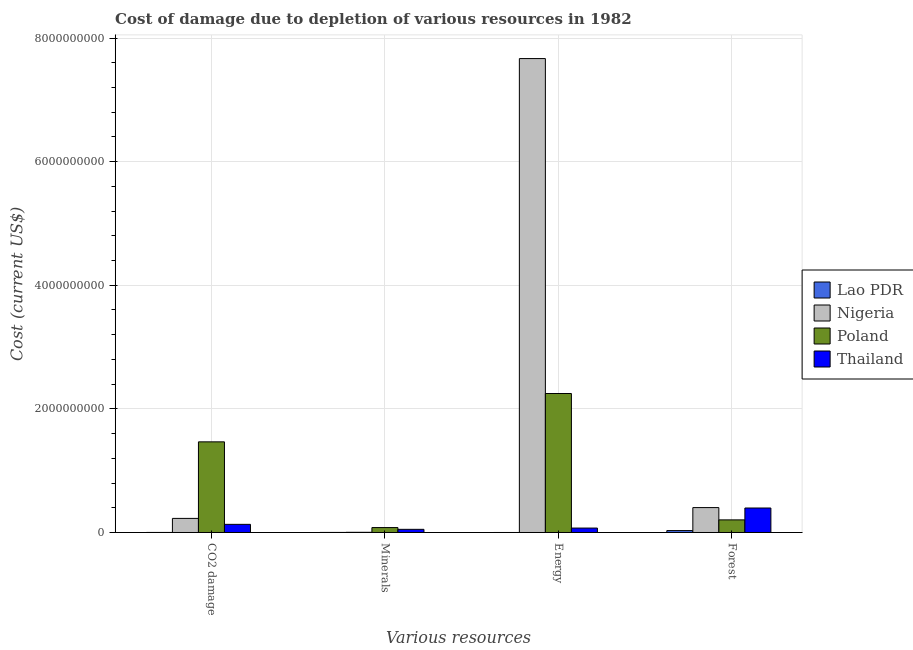How many different coloured bars are there?
Your answer should be compact. 4. How many groups of bars are there?
Your answer should be very brief. 4. Are the number of bars per tick equal to the number of legend labels?
Make the answer very short. Yes. Are the number of bars on each tick of the X-axis equal?
Ensure brevity in your answer.  Yes. How many bars are there on the 3rd tick from the left?
Make the answer very short. 4. How many bars are there on the 1st tick from the right?
Your answer should be compact. 4. What is the label of the 4th group of bars from the left?
Make the answer very short. Forest. What is the cost of damage due to depletion of forests in Lao PDR?
Provide a short and direct response. 3.10e+07. Across all countries, what is the maximum cost of damage due to depletion of minerals?
Your answer should be very brief. 7.95e+07. Across all countries, what is the minimum cost of damage due to depletion of forests?
Provide a short and direct response. 3.10e+07. In which country was the cost of damage due to depletion of forests minimum?
Your answer should be compact. Lao PDR. What is the total cost of damage due to depletion of forests in the graph?
Make the answer very short. 1.03e+09. What is the difference between the cost of damage due to depletion of forests in Thailand and that in Lao PDR?
Your answer should be compact. 3.65e+08. What is the difference between the cost of damage due to depletion of minerals in Nigeria and the cost of damage due to depletion of coal in Lao PDR?
Your answer should be very brief. 2.46e+06. What is the average cost of damage due to depletion of coal per country?
Make the answer very short. 4.57e+08. What is the difference between the cost of damage due to depletion of minerals and cost of damage due to depletion of energy in Thailand?
Provide a short and direct response. -2.06e+07. What is the ratio of the cost of damage due to depletion of energy in Lao PDR to that in Poland?
Provide a succinct answer. 1.882931711154583e-6. Is the cost of damage due to depletion of forests in Lao PDR less than that in Nigeria?
Your response must be concise. Yes. What is the difference between the highest and the second highest cost of damage due to depletion of energy?
Ensure brevity in your answer.  5.42e+09. What is the difference between the highest and the lowest cost of damage due to depletion of energy?
Keep it short and to the point. 7.67e+09. What does the 3rd bar from the right in Minerals represents?
Give a very brief answer. Nigeria. Is it the case that in every country, the sum of the cost of damage due to depletion of coal and cost of damage due to depletion of minerals is greater than the cost of damage due to depletion of energy?
Your response must be concise. No. How many bars are there?
Provide a succinct answer. 16. Are all the bars in the graph horizontal?
Your response must be concise. No. How many countries are there in the graph?
Keep it short and to the point. 4. Are the values on the major ticks of Y-axis written in scientific E-notation?
Provide a succinct answer. No. Does the graph contain any zero values?
Provide a short and direct response. No. Does the graph contain grids?
Your response must be concise. Yes. What is the title of the graph?
Offer a very short reply. Cost of damage due to depletion of various resources in 1982 . What is the label or title of the X-axis?
Your response must be concise. Various resources. What is the label or title of the Y-axis?
Your answer should be compact. Cost (current US$). What is the Cost (current US$) of Lao PDR in CO2 damage?
Provide a short and direct response. 5.48e+05. What is the Cost (current US$) in Nigeria in CO2 damage?
Your answer should be compact. 2.28e+08. What is the Cost (current US$) of Poland in CO2 damage?
Offer a terse response. 1.47e+09. What is the Cost (current US$) of Thailand in CO2 damage?
Keep it short and to the point. 1.32e+08. What is the Cost (current US$) of Lao PDR in Minerals?
Ensure brevity in your answer.  9.86e+05. What is the Cost (current US$) in Nigeria in Minerals?
Your answer should be compact. 3.01e+06. What is the Cost (current US$) of Poland in Minerals?
Offer a terse response. 7.95e+07. What is the Cost (current US$) in Thailand in Minerals?
Your answer should be very brief. 5.09e+07. What is the Cost (current US$) of Lao PDR in Energy?
Keep it short and to the point. 4233.79. What is the Cost (current US$) in Nigeria in Energy?
Offer a terse response. 7.67e+09. What is the Cost (current US$) in Poland in Energy?
Offer a terse response. 2.25e+09. What is the Cost (current US$) in Thailand in Energy?
Ensure brevity in your answer.  7.15e+07. What is the Cost (current US$) in Lao PDR in Forest?
Keep it short and to the point. 3.10e+07. What is the Cost (current US$) of Nigeria in Forest?
Provide a succinct answer. 4.03e+08. What is the Cost (current US$) in Poland in Forest?
Provide a succinct answer. 2.04e+08. What is the Cost (current US$) in Thailand in Forest?
Provide a succinct answer. 3.96e+08. Across all Various resources, what is the maximum Cost (current US$) in Lao PDR?
Your answer should be very brief. 3.10e+07. Across all Various resources, what is the maximum Cost (current US$) in Nigeria?
Offer a terse response. 7.67e+09. Across all Various resources, what is the maximum Cost (current US$) of Poland?
Offer a terse response. 2.25e+09. Across all Various resources, what is the maximum Cost (current US$) of Thailand?
Provide a short and direct response. 3.96e+08. Across all Various resources, what is the minimum Cost (current US$) in Lao PDR?
Your answer should be compact. 4233.79. Across all Various resources, what is the minimum Cost (current US$) in Nigeria?
Give a very brief answer. 3.01e+06. Across all Various resources, what is the minimum Cost (current US$) in Poland?
Your answer should be very brief. 7.95e+07. Across all Various resources, what is the minimum Cost (current US$) of Thailand?
Offer a very short reply. 5.09e+07. What is the total Cost (current US$) of Lao PDR in the graph?
Keep it short and to the point. 3.25e+07. What is the total Cost (current US$) in Nigeria in the graph?
Your answer should be very brief. 8.30e+09. What is the total Cost (current US$) of Poland in the graph?
Keep it short and to the point. 4.00e+09. What is the total Cost (current US$) of Thailand in the graph?
Make the answer very short. 6.50e+08. What is the difference between the Cost (current US$) of Lao PDR in CO2 damage and that in Minerals?
Your answer should be compact. -4.38e+05. What is the difference between the Cost (current US$) of Nigeria in CO2 damage and that in Minerals?
Make the answer very short. 2.25e+08. What is the difference between the Cost (current US$) of Poland in CO2 damage and that in Minerals?
Ensure brevity in your answer.  1.39e+09. What is the difference between the Cost (current US$) of Thailand in CO2 damage and that in Minerals?
Provide a short and direct response. 8.08e+07. What is the difference between the Cost (current US$) in Lao PDR in CO2 damage and that in Energy?
Offer a very short reply. 5.43e+05. What is the difference between the Cost (current US$) of Nigeria in CO2 damage and that in Energy?
Provide a succinct answer. -7.44e+09. What is the difference between the Cost (current US$) in Poland in CO2 damage and that in Energy?
Make the answer very short. -7.82e+08. What is the difference between the Cost (current US$) in Thailand in CO2 damage and that in Energy?
Your answer should be very brief. 6.02e+07. What is the difference between the Cost (current US$) of Lao PDR in CO2 damage and that in Forest?
Your answer should be very brief. -3.05e+07. What is the difference between the Cost (current US$) in Nigeria in CO2 damage and that in Forest?
Your answer should be very brief. -1.75e+08. What is the difference between the Cost (current US$) of Poland in CO2 damage and that in Forest?
Make the answer very short. 1.26e+09. What is the difference between the Cost (current US$) in Thailand in CO2 damage and that in Forest?
Keep it short and to the point. -2.64e+08. What is the difference between the Cost (current US$) of Lao PDR in Minerals and that in Energy?
Your answer should be compact. 9.82e+05. What is the difference between the Cost (current US$) of Nigeria in Minerals and that in Energy?
Offer a very short reply. -7.66e+09. What is the difference between the Cost (current US$) of Poland in Minerals and that in Energy?
Keep it short and to the point. -2.17e+09. What is the difference between the Cost (current US$) in Thailand in Minerals and that in Energy?
Provide a short and direct response. -2.06e+07. What is the difference between the Cost (current US$) of Lao PDR in Minerals and that in Forest?
Provide a succinct answer. -3.00e+07. What is the difference between the Cost (current US$) in Nigeria in Minerals and that in Forest?
Provide a short and direct response. -4.00e+08. What is the difference between the Cost (current US$) of Poland in Minerals and that in Forest?
Make the answer very short. -1.25e+08. What is the difference between the Cost (current US$) of Thailand in Minerals and that in Forest?
Make the answer very short. -3.45e+08. What is the difference between the Cost (current US$) of Lao PDR in Energy and that in Forest?
Give a very brief answer. -3.10e+07. What is the difference between the Cost (current US$) in Nigeria in Energy and that in Forest?
Provide a succinct answer. 7.26e+09. What is the difference between the Cost (current US$) of Poland in Energy and that in Forest?
Ensure brevity in your answer.  2.04e+09. What is the difference between the Cost (current US$) of Thailand in Energy and that in Forest?
Your answer should be very brief. -3.24e+08. What is the difference between the Cost (current US$) of Lao PDR in CO2 damage and the Cost (current US$) of Nigeria in Minerals?
Your answer should be compact. -2.46e+06. What is the difference between the Cost (current US$) in Lao PDR in CO2 damage and the Cost (current US$) in Poland in Minerals?
Offer a very short reply. -7.89e+07. What is the difference between the Cost (current US$) in Lao PDR in CO2 damage and the Cost (current US$) in Thailand in Minerals?
Your answer should be compact. -5.03e+07. What is the difference between the Cost (current US$) of Nigeria in CO2 damage and the Cost (current US$) of Poland in Minerals?
Ensure brevity in your answer.  1.48e+08. What is the difference between the Cost (current US$) of Nigeria in CO2 damage and the Cost (current US$) of Thailand in Minerals?
Make the answer very short. 1.77e+08. What is the difference between the Cost (current US$) in Poland in CO2 damage and the Cost (current US$) in Thailand in Minerals?
Your answer should be very brief. 1.42e+09. What is the difference between the Cost (current US$) in Lao PDR in CO2 damage and the Cost (current US$) in Nigeria in Energy?
Your answer should be very brief. -7.67e+09. What is the difference between the Cost (current US$) of Lao PDR in CO2 damage and the Cost (current US$) of Poland in Energy?
Your answer should be very brief. -2.25e+09. What is the difference between the Cost (current US$) of Lao PDR in CO2 damage and the Cost (current US$) of Thailand in Energy?
Offer a very short reply. -7.09e+07. What is the difference between the Cost (current US$) in Nigeria in CO2 damage and the Cost (current US$) in Poland in Energy?
Give a very brief answer. -2.02e+09. What is the difference between the Cost (current US$) of Nigeria in CO2 damage and the Cost (current US$) of Thailand in Energy?
Ensure brevity in your answer.  1.56e+08. What is the difference between the Cost (current US$) of Poland in CO2 damage and the Cost (current US$) of Thailand in Energy?
Make the answer very short. 1.39e+09. What is the difference between the Cost (current US$) of Lao PDR in CO2 damage and the Cost (current US$) of Nigeria in Forest?
Make the answer very short. -4.02e+08. What is the difference between the Cost (current US$) of Lao PDR in CO2 damage and the Cost (current US$) of Poland in Forest?
Keep it short and to the point. -2.03e+08. What is the difference between the Cost (current US$) of Lao PDR in CO2 damage and the Cost (current US$) of Thailand in Forest?
Your response must be concise. -3.95e+08. What is the difference between the Cost (current US$) in Nigeria in CO2 damage and the Cost (current US$) in Poland in Forest?
Your answer should be very brief. 2.38e+07. What is the difference between the Cost (current US$) in Nigeria in CO2 damage and the Cost (current US$) in Thailand in Forest?
Keep it short and to the point. -1.68e+08. What is the difference between the Cost (current US$) of Poland in CO2 damage and the Cost (current US$) of Thailand in Forest?
Your answer should be very brief. 1.07e+09. What is the difference between the Cost (current US$) of Lao PDR in Minerals and the Cost (current US$) of Nigeria in Energy?
Offer a very short reply. -7.67e+09. What is the difference between the Cost (current US$) of Lao PDR in Minerals and the Cost (current US$) of Poland in Energy?
Your answer should be compact. -2.25e+09. What is the difference between the Cost (current US$) of Lao PDR in Minerals and the Cost (current US$) of Thailand in Energy?
Offer a terse response. -7.05e+07. What is the difference between the Cost (current US$) of Nigeria in Minerals and the Cost (current US$) of Poland in Energy?
Make the answer very short. -2.25e+09. What is the difference between the Cost (current US$) in Nigeria in Minerals and the Cost (current US$) in Thailand in Energy?
Offer a very short reply. -6.85e+07. What is the difference between the Cost (current US$) of Poland in Minerals and the Cost (current US$) of Thailand in Energy?
Provide a succinct answer. 7.99e+06. What is the difference between the Cost (current US$) in Lao PDR in Minerals and the Cost (current US$) in Nigeria in Forest?
Ensure brevity in your answer.  -4.02e+08. What is the difference between the Cost (current US$) in Lao PDR in Minerals and the Cost (current US$) in Poland in Forest?
Offer a very short reply. -2.03e+08. What is the difference between the Cost (current US$) of Lao PDR in Minerals and the Cost (current US$) of Thailand in Forest?
Offer a terse response. -3.95e+08. What is the difference between the Cost (current US$) in Nigeria in Minerals and the Cost (current US$) in Poland in Forest?
Ensure brevity in your answer.  -2.01e+08. What is the difference between the Cost (current US$) in Nigeria in Minerals and the Cost (current US$) in Thailand in Forest?
Your response must be concise. -3.93e+08. What is the difference between the Cost (current US$) in Poland in Minerals and the Cost (current US$) in Thailand in Forest?
Make the answer very short. -3.16e+08. What is the difference between the Cost (current US$) in Lao PDR in Energy and the Cost (current US$) in Nigeria in Forest?
Provide a short and direct response. -4.03e+08. What is the difference between the Cost (current US$) of Lao PDR in Energy and the Cost (current US$) of Poland in Forest?
Offer a very short reply. -2.04e+08. What is the difference between the Cost (current US$) in Lao PDR in Energy and the Cost (current US$) in Thailand in Forest?
Your answer should be compact. -3.96e+08. What is the difference between the Cost (current US$) of Nigeria in Energy and the Cost (current US$) of Poland in Forest?
Your answer should be very brief. 7.46e+09. What is the difference between the Cost (current US$) of Nigeria in Energy and the Cost (current US$) of Thailand in Forest?
Your response must be concise. 7.27e+09. What is the difference between the Cost (current US$) in Poland in Energy and the Cost (current US$) in Thailand in Forest?
Give a very brief answer. 1.85e+09. What is the average Cost (current US$) of Lao PDR per Various resources?
Your answer should be compact. 8.13e+06. What is the average Cost (current US$) in Nigeria per Various resources?
Keep it short and to the point. 2.08e+09. What is the average Cost (current US$) of Poland per Various resources?
Ensure brevity in your answer.  1.00e+09. What is the average Cost (current US$) in Thailand per Various resources?
Your response must be concise. 1.62e+08. What is the difference between the Cost (current US$) of Lao PDR and Cost (current US$) of Nigeria in CO2 damage?
Offer a terse response. -2.27e+08. What is the difference between the Cost (current US$) in Lao PDR and Cost (current US$) in Poland in CO2 damage?
Offer a very short reply. -1.47e+09. What is the difference between the Cost (current US$) of Lao PDR and Cost (current US$) of Thailand in CO2 damage?
Make the answer very short. -1.31e+08. What is the difference between the Cost (current US$) in Nigeria and Cost (current US$) in Poland in CO2 damage?
Ensure brevity in your answer.  -1.24e+09. What is the difference between the Cost (current US$) of Nigeria and Cost (current US$) of Thailand in CO2 damage?
Your answer should be very brief. 9.62e+07. What is the difference between the Cost (current US$) of Poland and Cost (current US$) of Thailand in CO2 damage?
Keep it short and to the point. 1.33e+09. What is the difference between the Cost (current US$) in Lao PDR and Cost (current US$) in Nigeria in Minerals?
Your answer should be compact. -2.02e+06. What is the difference between the Cost (current US$) in Lao PDR and Cost (current US$) in Poland in Minerals?
Make the answer very short. -7.85e+07. What is the difference between the Cost (current US$) of Lao PDR and Cost (current US$) of Thailand in Minerals?
Offer a very short reply. -4.99e+07. What is the difference between the Cost (current US$) of Nigeria and Cost (current US$) of Poland in Minerals?
Give a very brief answer. -7.65e+07. What is the difference between the Cost (current US$) in Nigeria and Cost (current US$) in Thailand in Minerals?
Offer a terse response. -4.79e+07. What is the difference between the Cost (current US$) of Poland and Cost (current US$) of Thailand in Minerals?
Offer a very short reply. 2.86e+07. What is the difference between the Cost (current US$) in Lao PDR and Cost (current US$) in Nigeria in Energy?
Make the answer very short. -7.67e+09. What is the difference between the Cost (current US$) in Lao PDR and Cost (current US$) in Poland in Energy?
Provide a short and direct response. -2.25e+09. What is the difference between the Cost (current US$) of Lao PDR and Cost (current US$) of Thailand in Energy?
Keep it short and to the point. -7.15e+07. What is the difference between the Cost (current US$) in Nigeria and Cost (current US$) in Poland in Energy?
Make the answer very short. 5.42e+09. What is the difference between the Cost (current US$) in Nigeria and Cost (current US$) in Thailand in Energy?
Offer a very short reply. 7.60e+09. What is the difference between the Cost (current US$) in Poland and Cost (current US$) in Thailand in Energy?
Make the answer very short. 2.18e+09. What is the difference between the Cost (current US$) in Lao PDR and Cost (current US$) in Nigeria in Forest?
Ensure brevity in your answer.  -3.72e+08. What is the difference between the Cost (current US$) of Lao PDR and Cost (current US$) of Poland in Forest?
Keep it short and to the point. -1.73e+08. What is the difference between the Cost (current US$) of Lao PDR and Cost (current US$) of Thailand in Forest?
Provide a succinct answer. -3.65e+08. What is the difference between the Cost (current US$) in Nigeria and Cost (current US$) in Poland in Forest?
Your answer should be very brief. 1.99e+08. What is the difference between the Cost (current US$) of Nigeria and Cost (current US$) of Thailand in Forest?
Make the answer very short. 6.84e+06. What is the difference between the Cost (current US$) of Poland and Cost (current US$) of Thailand in Forest?
Provide a succinct answer. -1.92e+08. What is the ratio of the Cost (current US$) of Lao PDR in CO2 damage to that in Minerals?
Ensure brevity in your answer.  0.56. What is the ratio of the Cost (current US$) in Nigeria in CO2 damage to that in Minerals?
Provide a short and direct response. 75.73. What is the ratio of the Cost (current US$) of Poland in CO2 damage to that in Minerals?
Provide a succinct answer. 18.45. What is the ratio of the Cost (current US$) of Thailand in CO2 damage to that in Minerals?
Provide a succinct answer. 2.59. What is the ratio of the Cost (current US$) in Lao PDR in CO2 damage to that in Energy?
Ensure brevity in your answer.  129.35. What is the ratio of the Cost (current US$) in Nigeria in CO2 damage to that in Energy?
Give a very brief answer. 0.03. What is the ratio of the Cost (current US$) of Poland in CO2 damage to that in Energy?
Your answer should be very brief. 0.65. What is the ratio of the Cost (current US$) of Thailand in CO2 damage to that in Energy?
Provide a succinct answer. 1.84. What is the ratio of the Cost (current US$) in Lao PDR in CO2 damage to that in Forest?
Give a very brief answer. 0.02. What is the ratio of the Cost (current US$) of Nigeria in CO2 damage to that in Forest?
Your answer should be compact. 0.57. What is the ratio of the Cost (current US$) in Poland in CO2 damage to that in Forest?
Offer a terse response. 7.19. What is the ratio of the Cost (current US$) in Thailand in CO2 damage to that in Forest?
Ensure brevity in your answer.  0.33. What is the ratio of the Cost (current US$) in Lao PDR in Minerals to that in Energy?
Offer a very short reply. 232.88. What is the ratio of the Cost (current US$) in Nigeria in Minerals to that in Energy?
Provide a succinct answer. 0. What is the ratio of the Cost (current US$) of Poland in Minerals to that in Energy?
Make the answer very short. 0.04. What is the ratio of the Cost (current US$) of Thailand in Minerals to that in Energy?
Give a very brief answer. 0.71. What is the ratio of the Cost (current US$) of Lao PDR in Minerals to that in Forest?
Your answer should be very brief. 0.03. What is the ratio of the Cost (current US$) of Nigeria in Minerals to that in Forest?
Provide a short and direct response. 0.01. What is the ratio of the Cost (current US$) of Poland in Minerals to that in Forest?
Your answer should be compact. 0.39. What is the ratio of the Cost (current US$) of Thailand in Minerals to that in Forest?
Keep it short and to the point. 0.13. What is the ratio of the Cost (current US$) of Lao PDR in Energy to that in Forest?
Offer a very short reply. 0. What is the ratio of the Cost (current US$) of Nigeria in Energy to that in Forest?
Offer a terse response. 19.04. What is the ratio of the Cost (current US$) in Poland in Energy to that in Forest?
Your answer should be compact. 11.02. What is the ratio of the Cost (current US$) in Thailand in Energy to that in Forest?
Offer a terse response. 0.18. What is the difference between the highest and the second highest Cost (current US$) in Lao PDR?
Provide a short and direct response. 3.00e+07. What is the difference between the highest and the second highest Cost (current US$) of Nigeria?
Give a very brief answer. 7.26e+09. What is the difference between the highest and the second highest Cost (current US$) in Poland?
Your answer should be compact. 7.82e+08. What is the difference between the highest and the second highest Cost (current US$) of Thailand?
Provide a succinct answer. 2.64e+08. What is the difference between the highest and the lowest Cost (current US$) of Lao PDR?
Your answer should be very brief. 3.10e+07. What is the difference between the highest and the lowest Cost (current US$) of Nigeria?
Provide a short and direct response. 7.66e+09. What is the difference between the highest and the lowest Cost (current US$) of Poland?
Offer a terse response. 2.17e+09. What is the difference between the highest and the lowest Cost (current US$) of Thailand?
Ensure brevity in your answer.  3.45e+08. 